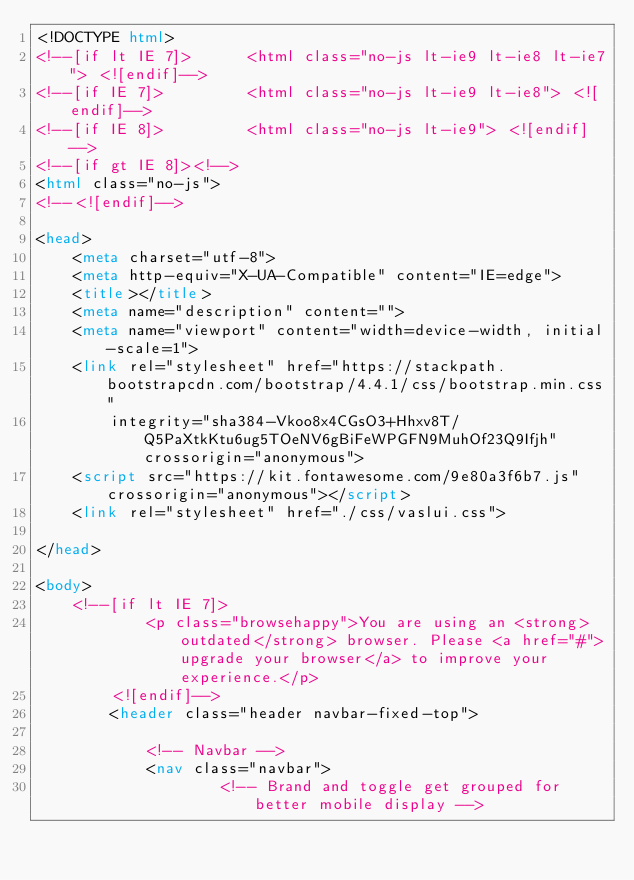Convert code to text. <code><loc_0><loc_0><loc_500><loc_500><_HTML_><!DOCTYPE html>
<!--[if lt IE 7]>      <html class="no-js lt-ie9 lt-ie8 lt-ie7"> <![endif]-->
<!--[if IE 7]>         <html class="no-js lt-ie9 lt-ie8"> <![endif]-->
<!--[if IE 8]>         <html class="no-js lt-ie9"> <![endif]-->
<!--[if gt IE 8]><!-->
<html class="no-js">
<!--<![endif]-->

<head>
    <meta charset="utf-8">
    <meta http-equiv="X-UA-Compatible" content="IE=edge">
    <title></title>
    <meta name="description" content="">
    <meta name="viewport" content="width=device-width, initial-scale=1">
    <link rel="stylesheet" href="https://stackpath.bootstrapcdn.com/bootstrap/4.4.1/css/bootstrap.min.css"
        integrity="sha384-Vkoo8x4CGsO3+Hhxv8T/Q5PaXtkKtu6ug5TOeNV6gBiFeWPGFN9MuhOf23Q9Ifjh" crossorigin="anonymous">
    <script src="https://kit.fontawesome.com/9e80a3f6b7.js" crossorigin="anonymous"></script>
    <link rel="stylesheet" href="./css/vaslui.css">

</head>

<body>
    <!--[if lt IE 7]>
            <p class="browsehappy">You are using an <strong>outdated</strong> browser. Please <a href="#">upgrade your browser</a> to improve your experience.</p>
        <![endif]-->
        <header class="header navbar-fixed-top">
  
            <!-- Navbar -->
            <nav class="navbar">
                    <!-- Brand and toggle get grouped for better mobile display -->
                    </code> 